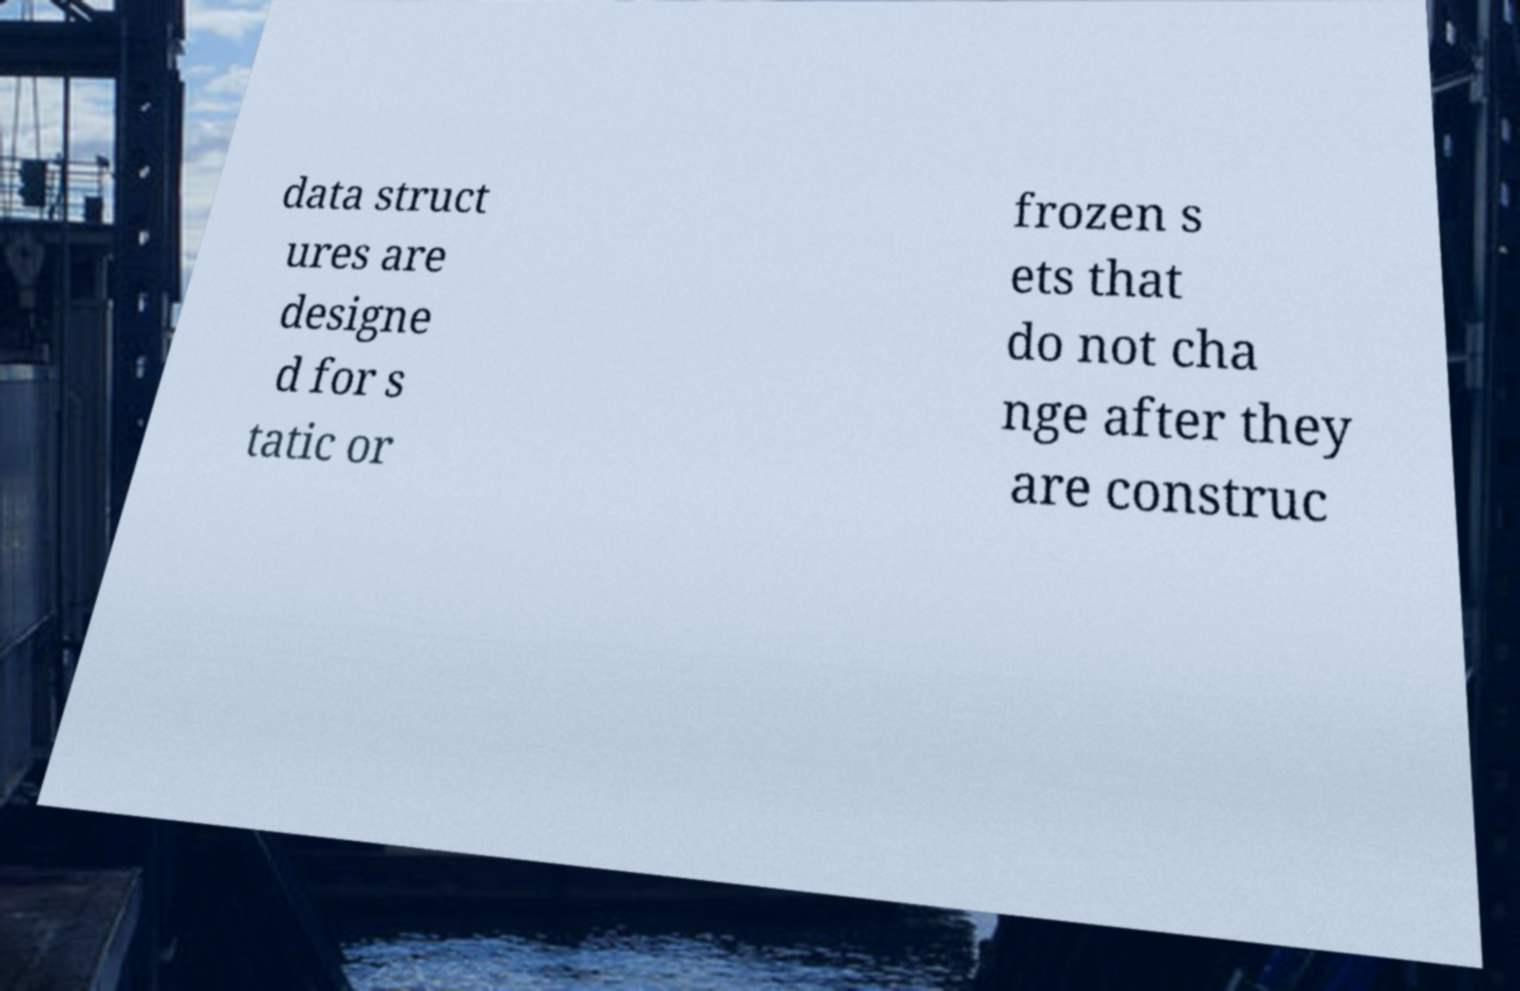For documentation purposes, I need the text within this image transcribed. Could you provide that? data struct ures are designe d for s tatic or frozen s ets that do not cha nge after they are construc 